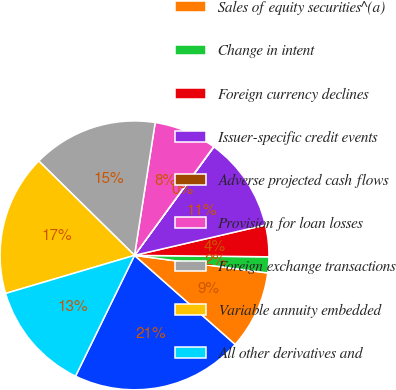Convert chart to OTSL. <chart><loc_0><loc_0><loc_500><loc_500><pie_chart><fcel>Years Ended December 31 (in<fcel>Sales of equity securities^(a)<fcel>Change in intent<fcel>Foreign currency declines<fcel>Issuer-specific credit events<fcel>Adverse projected cash flows<fcel>Provision for loan losses<fcel>Foreign exchange transactions<fcel>Variable annuity embedded<fcel>All other derivatives and<nl><fcel>20.71%<fcel>9.44%<fcel>1.92%<fcel>3.8%<fcel>11.32%<fcel>0.04%<fcel>7.56%<fcel>15.08%<fcel>16.96%<fcel>13.2%<nl></chart> 